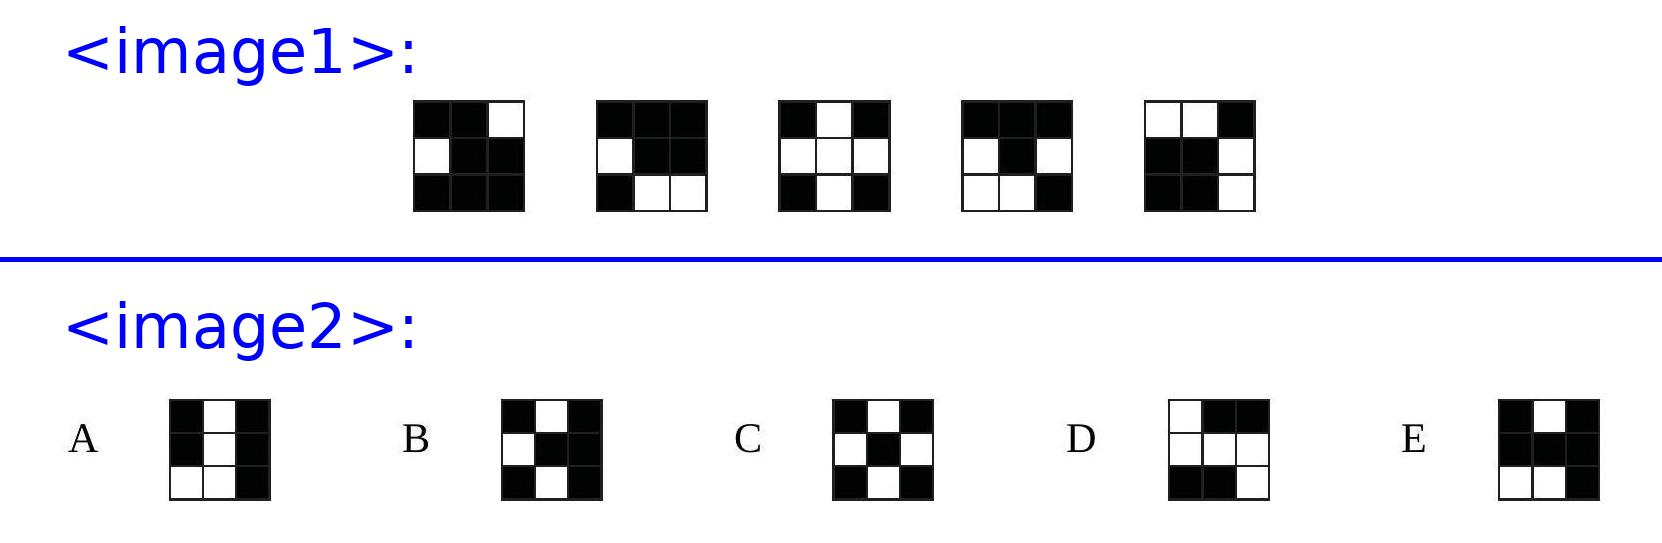Explore the visible patterns on the five cube faces shown. Discuss how these patterns could relate to possible configurations of the unseen sixth face. Each face of the cube shows a unique combination of black and white cubes. We should consider how these patterns ensure the total number of black and white cubes remains consistent throughout the cube. To predict the unseen face, observe the distribution of colors in the shown faces to deduce a likely pattern that balances the overall cube configuration. 